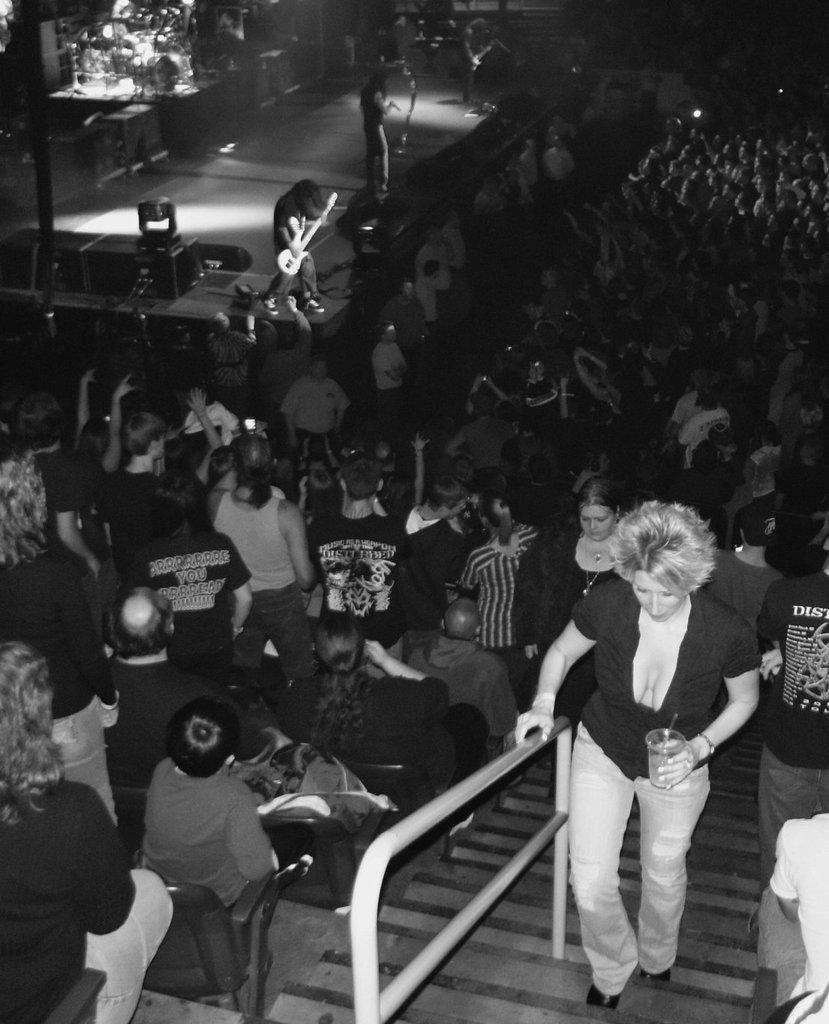Can you describe this image briefly? In this picture we can see group of people and lights, on the right side of the image we can see a woman, she is holding a glass, in the background we can find few people playing musical instruments. 